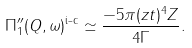<formula> <loc_0><loc_0><loc_500><loc_500>\Pi ^ { \prime \prime } _ { 1 } ( { Q } , \omega ) ^ { \text {i-c} } \simeq \frac { - 5 \pi ( z t ) ^ { 4 } Z } { 4 \Gamma } .</formula> 